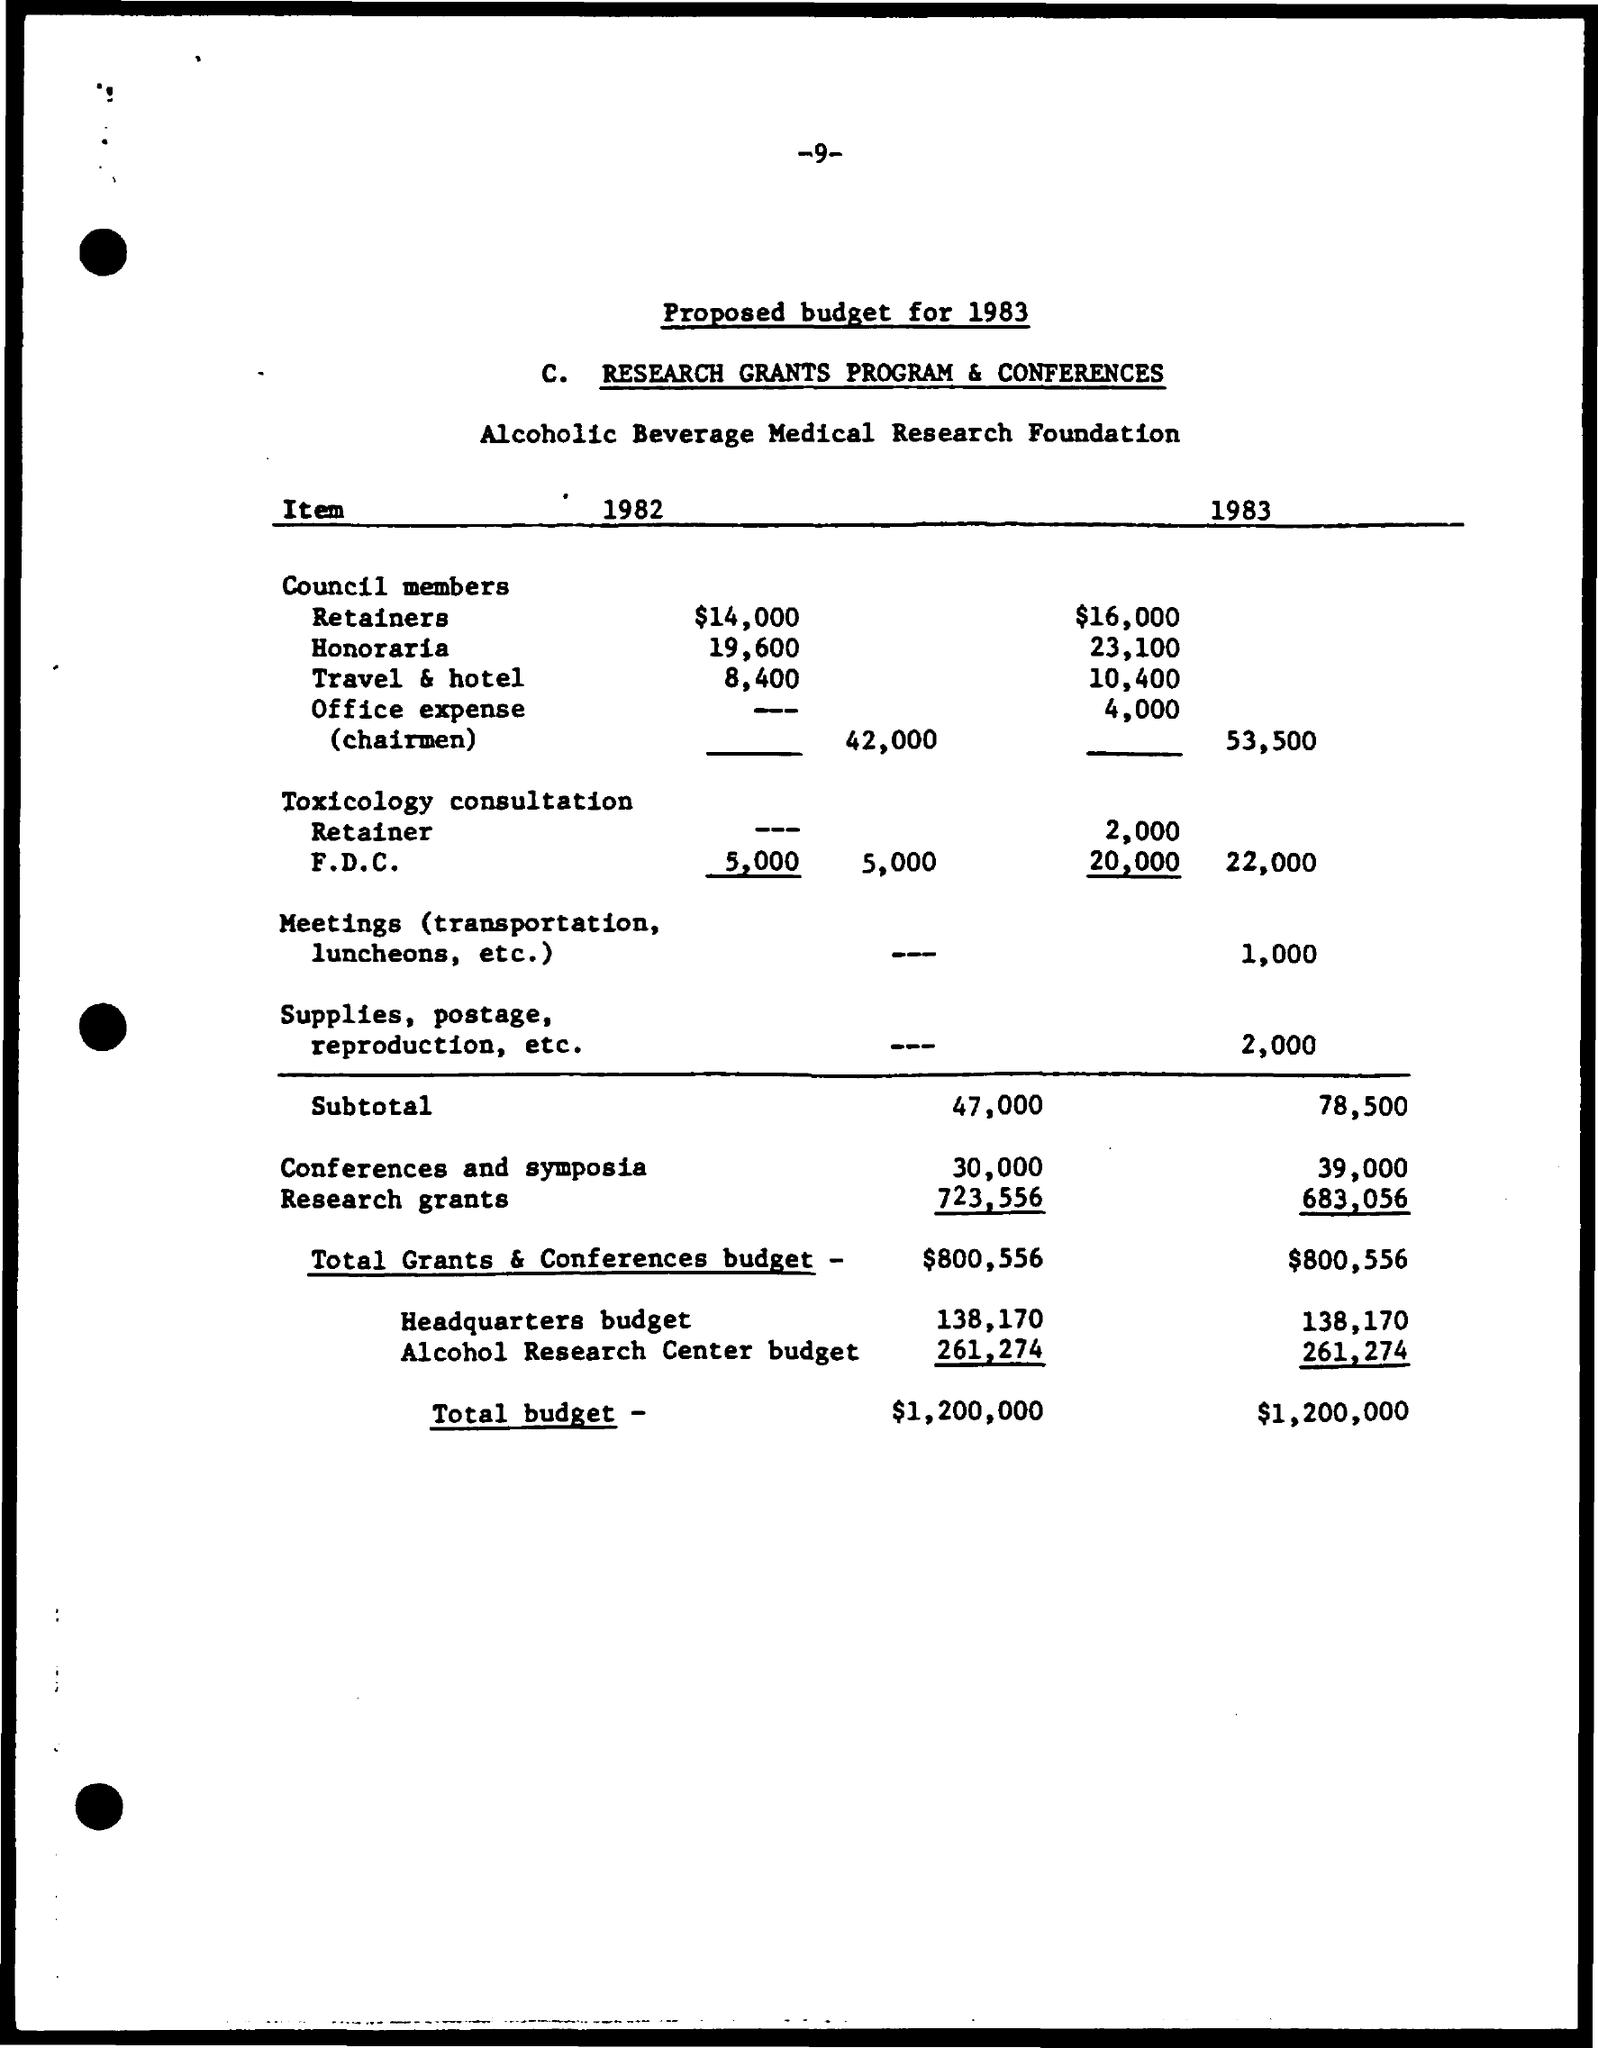Mention a couple of crucial points in this snapshot. As of 1983, the cost for retainers was 16,000. The subtotal for 1982 is 47,000. The subtotal for 1983 is 78,500. In 1983, the cost for travel and hotel was 10,400. Please provide the title of the document in question: 'Proposed budget for 1983.' 